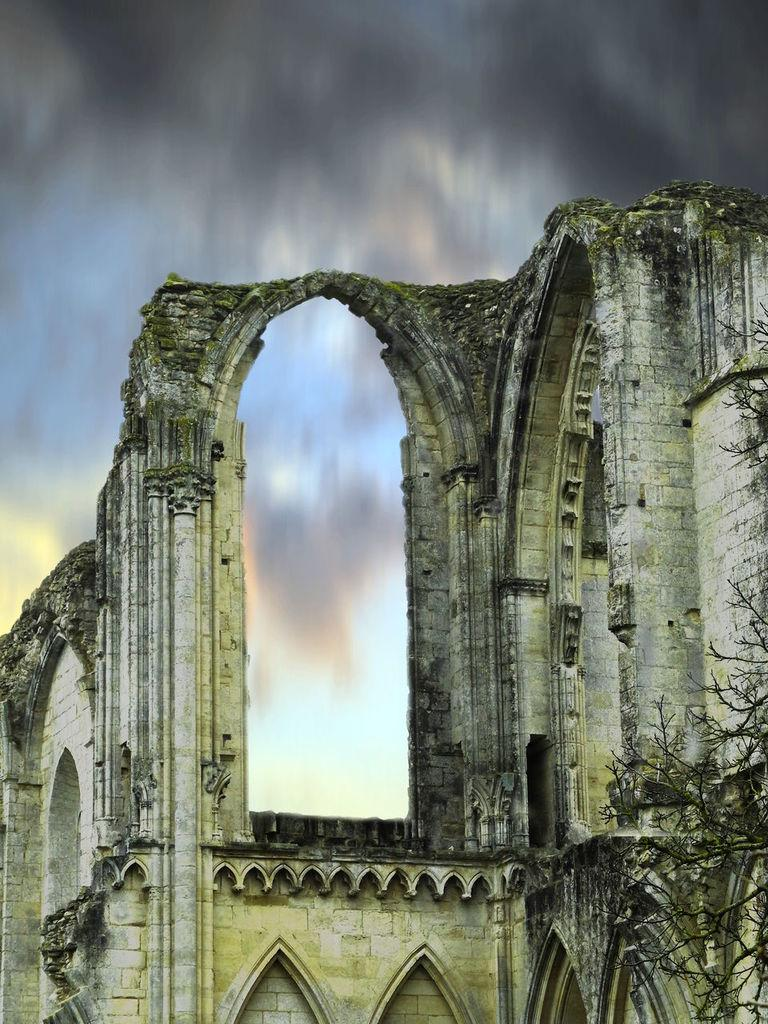What type of structure is present in the image? There is a building in the image. What colors are used for the building? The building is in white and green color. What can be seen on the right side of the image? There is a dried tree on the right side of the image. What is visible in the background of the image? There is a sky visible in the background of the image. What can be observed in the sky? There are clouds in the sky. How many crates are stacked next to the building in the image? There are no crates present in the image. What type of lizards can be seen crawling on the building in the image? There are no lizards present in the image. 